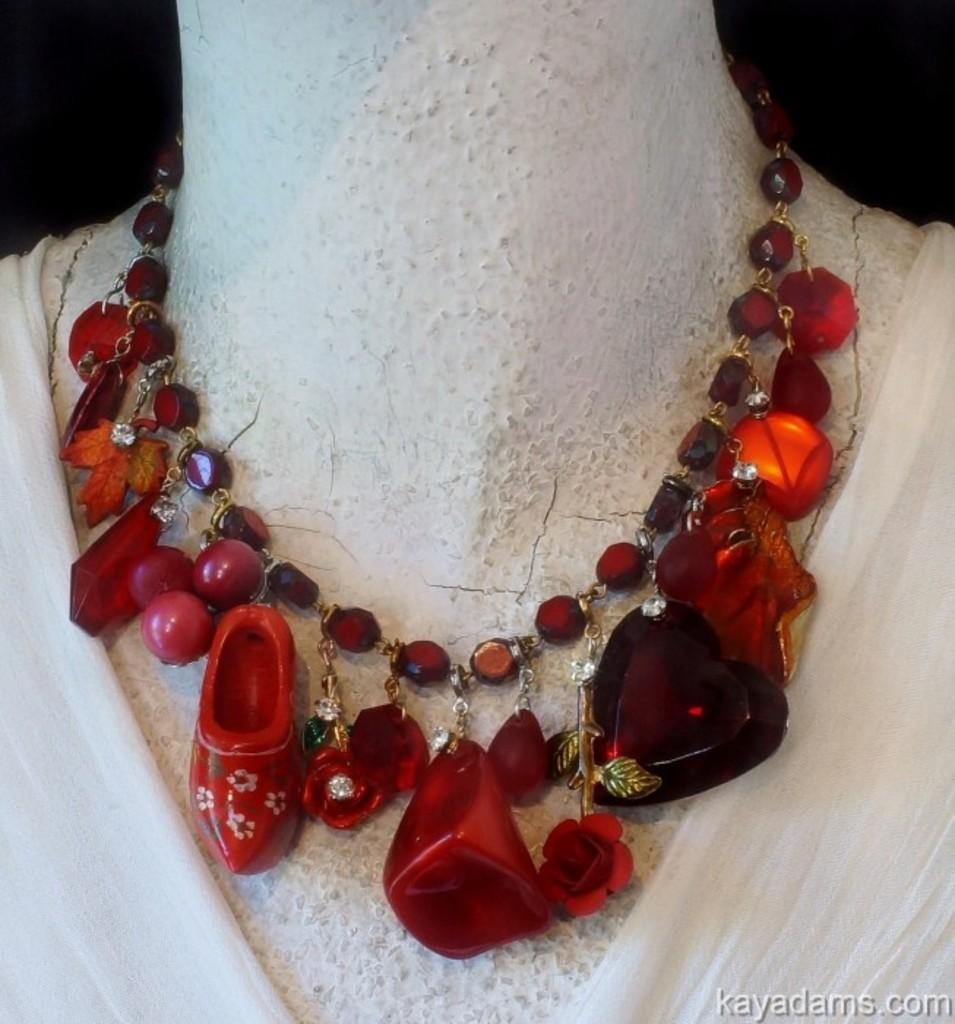What color is the necklace in the image? The necklace in the image is red. Where is the necklace located in the image? The necklace is on a mannequin. What color is the cloth in the bottom right of the image? The cloth in the bottom right of the image is white. What color is the cloth in the bottom left of the image? The cloth in the bottom left of the image is also white. Can you tell me how many oatmeal containers are visible in the image? There are no oatmeal containers present in the image. What type of coastline can be seen in the image? There is no coastline visible in the image; it features a red necklace on a mannequin and white cloth in the bottom corners. 